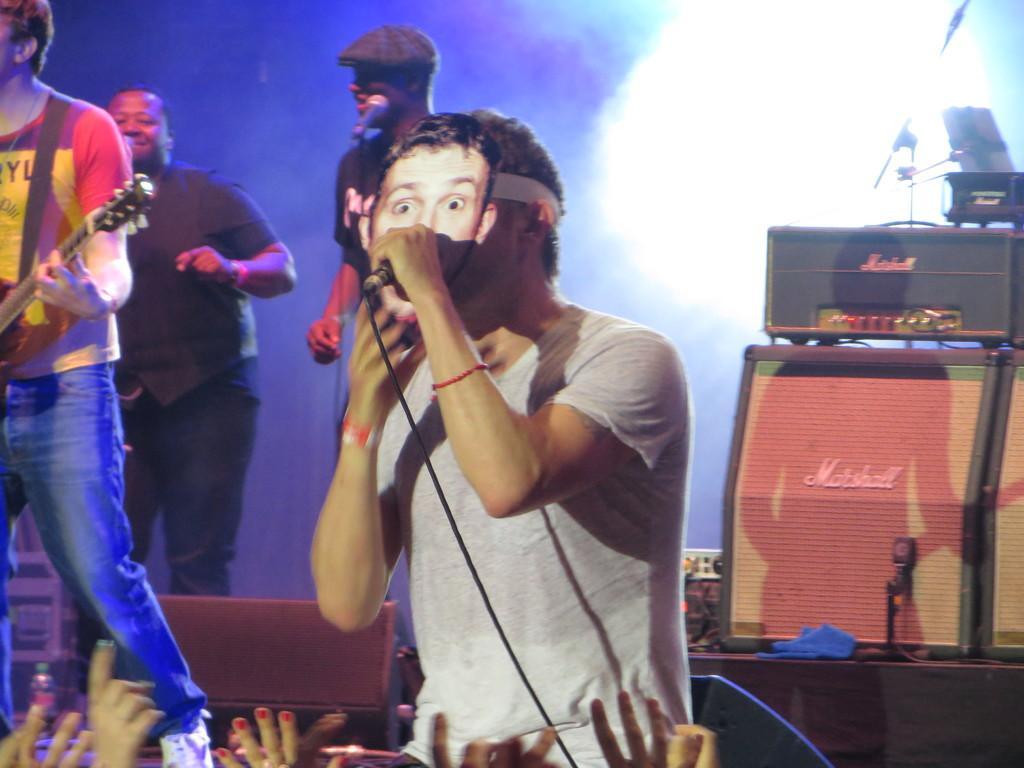Can you describe this image briefly? This image describes about group of people, in the middle of the given image is singing with the help of microphone, in the left side of the image a man is playing guitar, in the background we can see some musical instruments and lights. 